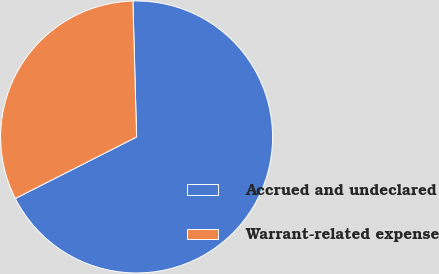<chart> <loc_0><loc_0><loc_500><loc_500><pie_chart><fcel>Accrued and undeclared<fcel>Warrant-related expense<nl><fcel>67.96%<fcel>32.04%<nl></chart> 